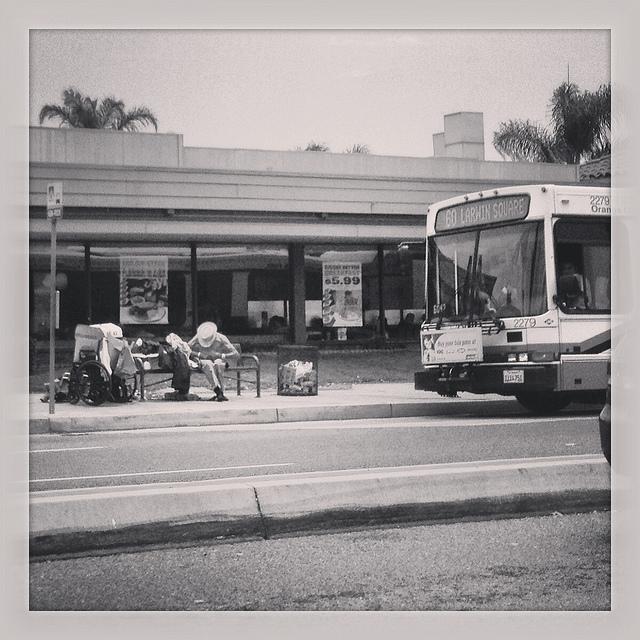What is the phone number on the food truck at left?
Give a very brief answer. No food truck. What digits can be seen on the license plate?
Short answer required. 0. Is there any color in this photo?
Concise answer only. No. Who is sitting in the wheelchair?
Answer briefly. No one. What kind of soda is advertised over the door?
Be succinct. Coke. Is this picture blurry?
Write a very short answer. No. What year was this?
Give a very brief answer. 1950. What is the man sitting on?
Be succinct. Bench. 